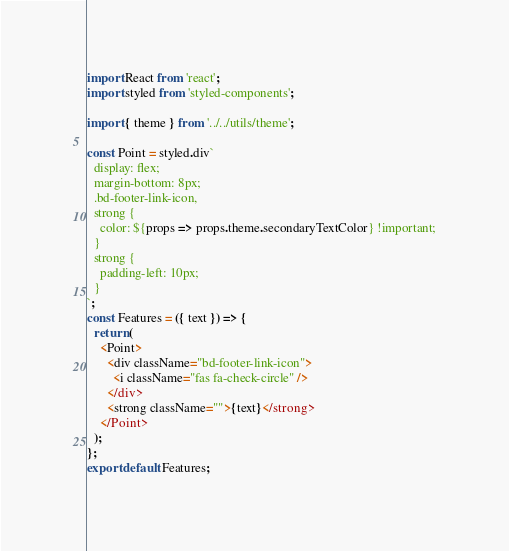Convert code to text. <code><loc_0><loc_0><loc_500><loc_500><_JavaScript_>import React from 'react';
import styled from 'styled-components';

import { theme } from '../../utils/theme';

const Point = styled.div`
  display: flex;
  margin-bottom: 8px;
  .bd-footer-link-icon,
  strong {
    color: ${props => props.theme.secondaryTextColor} !important;
  }
  strong {
    padding-left: 10px;
  }
`;
const Features = ({ text }) => {
  return (
    <Point>
      <div className="bd-footer-link-icon">
        <i className="fas fa-check-circle" />
      </div>
      <strong className="">{text}</strong>
    </Point>
  );
};
export default Features;
</code> 